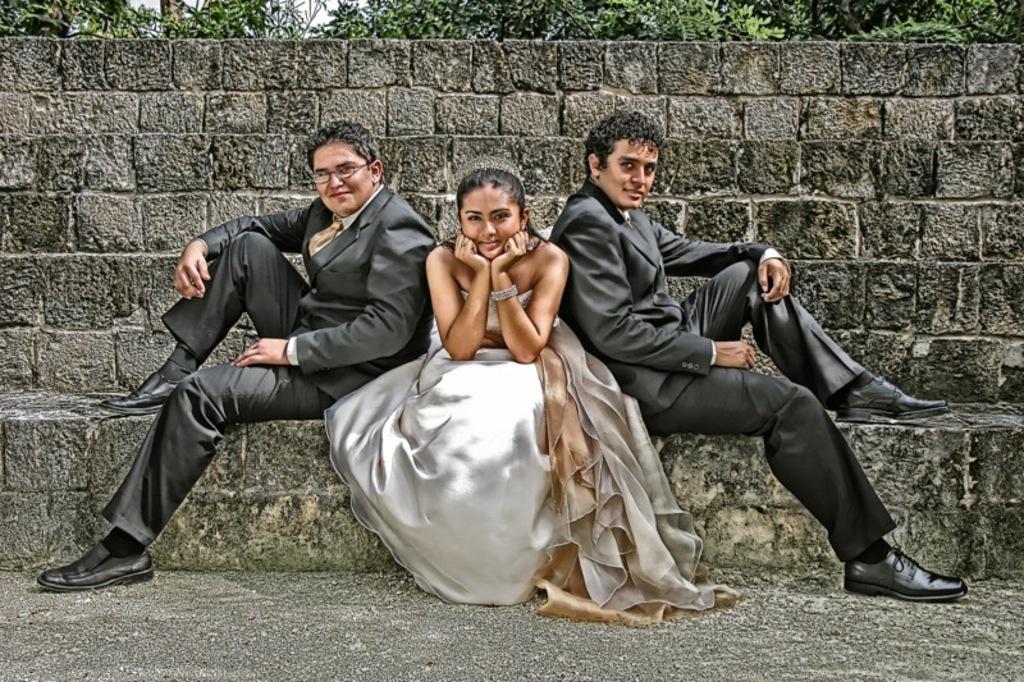How would you summarize this image in a sentence or two? In the picture I can see two men wearing black color blazers and shoes are sitting on the steps and they are on the either of the image. Here we can see a woman wearing a white color dress is also sitting in the middle. In the background, we can see the stone wall and trees. 